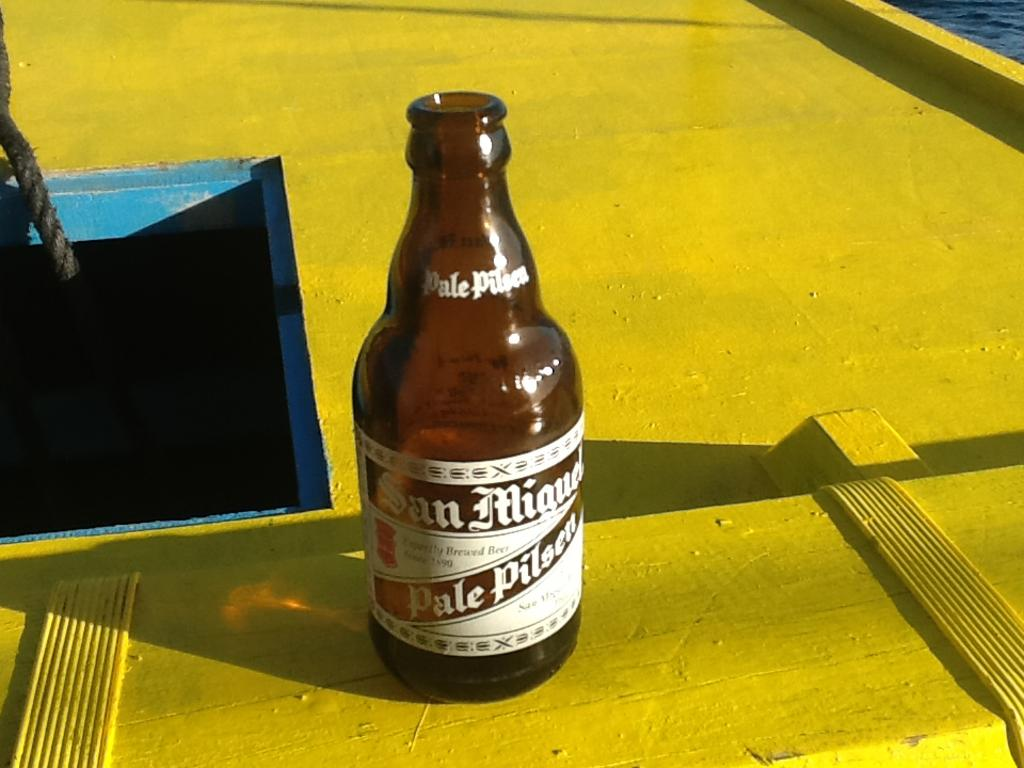<image>
Describe the image concisely. A San Miguel bottle sits on a yellow surface. 